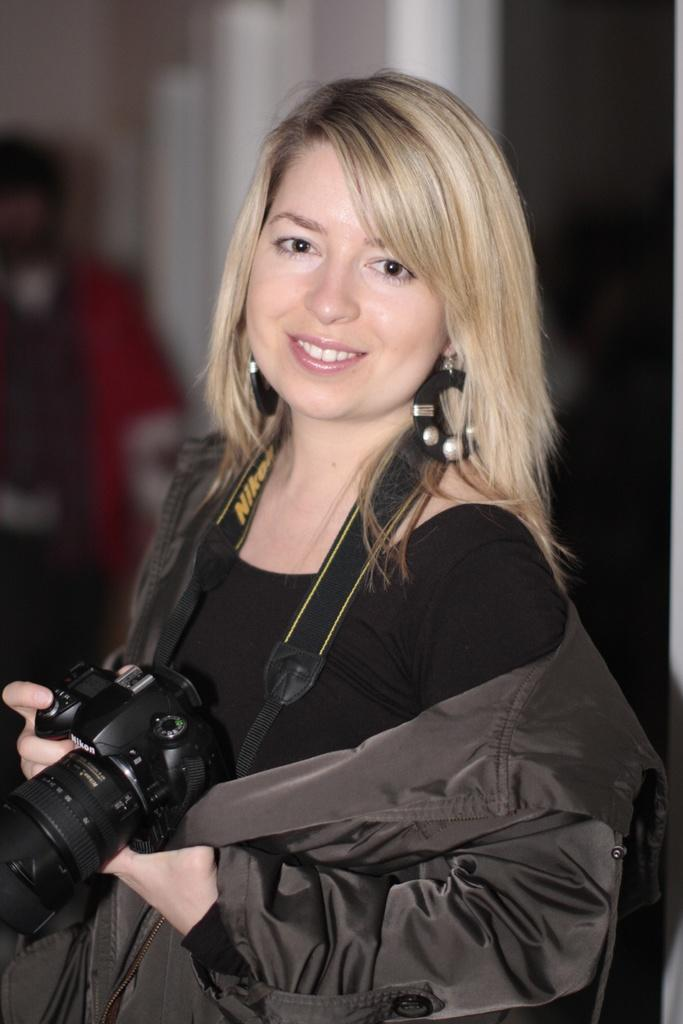Who is the main subject in the image? There is a girl in the image. What is the girl wearing? The girl is wearing a black jacket. What is the girl's posture in the image? The girl is standing. What is the girl holding in her hand? The girl is holding a camera in her hand. What is the girl's facial expression in the image? The girl is smiling. What is the girl's income in the image? There is no information about the girl's income in the image. How can we help the girl in the image? There is no need to help the girl in the image, as she appears to be happy and engaged in a positive activity. 